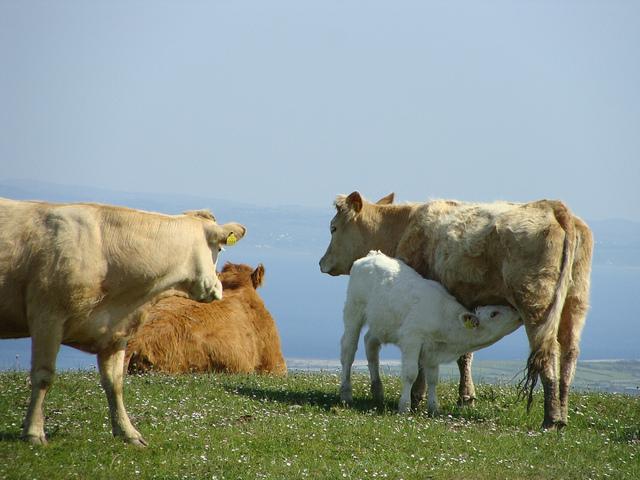How many adult cows are in the photo?
Concise answer only. 3. Are the cows curious?
Keep it brief. No. Is the calf hungry?
Be succinct. Yes. Which sheep is the oldest?
Concise answer only. No sheep. Is the white cow feeding?
Short answer required. Yes. 